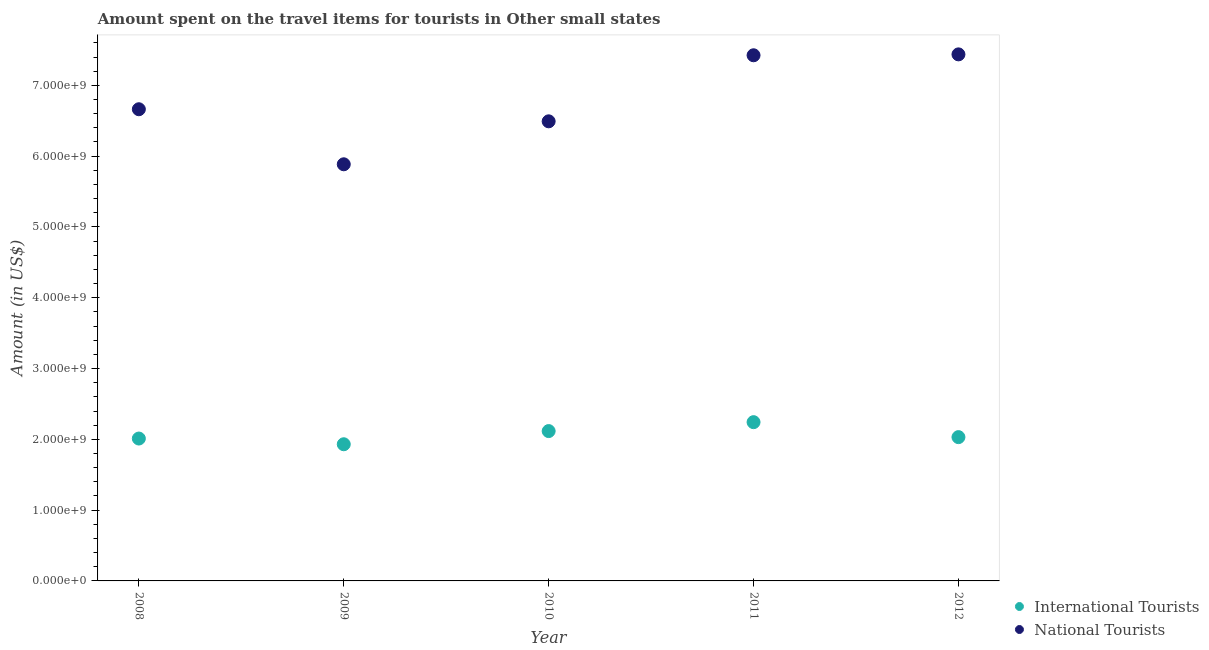How many different coloured dotlines are there?
Provide a short and direct response. 2. What is the amount spent on travel items of national tourists in 2008?
Give a very brief answer. 6.66e+09. Across all years, what is the maximum amount spent on travel items of national tourists?
Your response must be concise. 7.44e+09. Across all years, what is the minimum amount spent on travel items of international tourists?
Provide a short and direct response. 1.93e+09. In which year was the amount spent on travel items of national tourists maximum?
Keep it short and to the point. 2012. What is the total amount spent on travel items of national tourists in the graph?
Ensure brevity in your answer.  3.39e+1. What is the difference between the amount spent on travel items of national tourists in 2010 and that in 2011?
Offer a terse response. -9.33e+08. What is the difference between the amount spent on travel items of national tourists in 2012 and the amount spent on travel items of international tourists in 2009?
Your answer should be very brief. 5.51e+09. What is the average amount spent on travel items of national tourists per year?
Offer a very short reply. 6.78e+09. In the year 2008, what is the difference between the amount spent on travel items of national tourists and amount spent on travel items of international tourists?
Give a very brief answer. 4.65e+09. In how many years, is the amount spent on travel items of national tourists greater than 6200000000 US$?
Offer a very short reply. 4. What is the ratio of the amount spent on travel items of international tourists in 2008 to that in 2011?
Keep it short and to the point. 0.9. Is the amount spent on travel items of international tourists in 2009 less than that in 2011?
Offer a very short reply. Yes. What is the difference between the highest and the second highest amount spent on travel items of international tourists?
Give a very brief answer. 1.26e+08. What is the difference between the highest and the lowest amount spent on travel items of national tourists?
Offer a very short reply. 1.55e+09. Is the amount spent on travel items of international tourists strictly greater than the amount spent on travel items of national tourists over the years?
Offer a terse response. No. Is the amount spent on travel items of national tourists strictly less than the amount spent on travel items of international tourists over the years?
Provide a short and direct response. No. How many dotlines are there?
Your response must be concise. 2. How many years are there in the graph?
Your answer should be very brief. 5. What is the difference between two consecutive major ticks on the Y-axis?
Offer a terse response. 1.00e+09. Does the graph contain any zero values?
Provide a succinct answer. No. What is the title of the graph?
Provide a succinct answer. Amount spent on the travel items for tourists in Other small states. What is the Amount (in US$) of International Tourists in 2008?
Ensure brevity in your answer.  2.01e+09. What is the Amount (in US$) in National Tourists in 2008?
Offer a terse response. 6.66e+09. What is the Amount (in US$) in International Tourists in 2009?
Keep it short and to the point. 1.93e+09. What is the Amount (in US$) of National Tourists in 2009?
Your answer should be very brief. 5.88e+09. What is the Amount (in US$) of International Tourists in 2010?
Provide a short and direct response. 2.12e+09. What is the Amount (in US$) of National Tourists in 2010?
Your answer should be very brief. 6.49e+09. What is the Amount (in US$) in International Tourists in 2011?
Your answer should be very brief. 2.24e+09. What is the Amount (in US$) in National Tourists in 2011?
Ensure brevity in your answer.  7.42e+09. What is the Amount (in US$) in International Tourists in 2012?
Give a very brief answer. 2.03e+09. What is the Amount (in US$) of National Tourists in 2012?
Keep it short and to the point. 7.44e+09. Across all years, what is the maximum Amount (in US$) of International Tourists?
Your answer should be compact. 2.24e+09. Across all years, what is the maximum Amount (in US$) in National Tourists?
Make the answer very short. 7.44e+09. Across all years, what is the minimum Amount (in US$) in International Tourists?
Your response must be concise. 1.93e+09. Across all years, what is the minimum Amount (in US$) in National Tourists?
Give a very brief answer. 5.88e+09. What is the total Amount (in US$) in International Tourists in the graph?
Offer a terse response. 1.03e+1. What is the total Amount (in US$) of National Tourists in the graph?
Keep it short and to the point. 3.39e+1. What is the difference between the Amount (in US$) of International Tourists in 2008 and that in 2009?
Provide a succinct answer. 8.07e+07. What is the difference between the Amount (in US$) in National Tourists in 2008 and that in 2009?
Provide a succinct answer. 7.78e+08. What is the difference between the Amount (in US$) of International Tourists in 2008 and that in 2010?
Ensure brevity in your answer.  -1.05e+08. What is the difference between the Amount (in US$) in National Tourists in 2008 and that in 2010?
Provide a succinct answer. 1.71e+08. What is the difference between the Amount (in US$) in International Tourists in 2008 and that in 2011?
Offer a very short reply. -2.31e+08. What is the difference between the Amount (in US$) of National Tourists in 2008 and that in 2011?
Ensure brevity in your answer.  -7.62e+08. What is the difference between the Amount (in US$) of International Tourists in 2008 and that in 2012?
Make the answer very short. -1.99e+07. What is the difference between the Amount (in US$) of National Tourists in 2008 and that in 2012?
Ensure brevity in your answer.  -7.75e+08. What is the difference between the Amount (in US$) of International Tourists in 2009 and that in 2010?
Give a very brief answer. -1.86e+08. What is the difference between the Amount (in US$) in National Tourists in 2009 and that in 2010?
Offer a very short reply. -6.07e+08. What is the difference between the Amount (in US$) in International Tourists in 2009 and that in 2011?
Offer a very short reply. -3.12e+08. What is the difference between the Amount (in US$) of National Tourists in 2009 and that in 2011?
Provide a short and direct response. -1.54e+09. What is the difference between the Amount (in US$) in International Tourists in 2009 and that in 2012?
Offer a very short reply. -1.01e+08. What is the difference between the Amount (in US$) of National Tourists in 2009 and that in 2012?
Offer a terse response. -1.55e+09. What is the difference between the Amount (in US$) in International Tourists in 2010 and that in 2011?
Provide a short and direct response. -1.26e+08. What is the difference between the Amount (in US$) in National Tourists in 2010 and that in 2011?
Offer a very short reply. -9.33e+08. What is the difference between the Amount (in US$) in International Tourists in 2010 and that in 2012?
Offer a very short reply. 8.54e+07. What is the difference between the Amount (in US$) in National Tourists in 2010 and that in 2012?
Keep it short and to the point. -9.46e+08. What is the difference between the Amount (in US$) in International Tourists in 2011 and that in 2012?
Give a very brief answer. 2.11e+08. What is the difference between the Amount (in US$) of National Tourists in 2011 and that in 2012?
Give a very brief answer. -1.28e+07. What is the difference between the Amount (in US$) of International Tourists in 2008 and the Amount (in US$) of National Tourists in 2009?
Make the answer very short. -3.87e+09. What is the difference between the Amount (in US$) in International Tourists in 2008 and the Amount (in US$) in National Tourists in 2010?
Provide a succinct answer. -4.48e+09. What is the difference between the Amount (in US$) in International Tourists in 2008 and the Amount (in US$) in National Tourists in 2011?
Ensure brevity in your answer.  -5.41e+09. What is the difference between the Amount (in US$) in International Tourists in 2008 and the Amount (in US$) in National Tourists in 2012?
Provide a succinct answer. -5.43e+09. What is the difference between the Amount (in US$) in International Tourists in 2009 and the Amount (in US$) in National Tourists in 2010?
Offer a terse response. -4.56e+09. What is the difference between the Amount (in US$) of International Tourists in 2009 and the Amount (in US$) of National Tourists in 2011?
Your response must be concise. -5.49e+09. What is the difference between the Amount (in US$) in International Tourists in 2009 and the Amount (in US$) in National Tourists in 2012?
Your answer should be very brief. -5.51e+09. What is the difference between the Amount (in US$) in International Tourists in 2010 and the Amount (in US$) in National Tourists in 2011?
Your response must be concise. -5.31e+09. What is the difference between the Amount (in US$) of International Tourists in 2010 and the Amount (in US$) of National Tourists in 2012?
Ensure brevity in your answer.  -5.32e+09. What is the difference between the Amount (in US$) in International Tourists in 2011 and the Amount (in US$) in National Tourists in 2012?
Provide a succinct answer. -5.20e+09. What is the average Amount (in US$) of International Tourists per year?
Offer a very short reply. 2.07e+09. What is the average Amount (in US$) of National Tourists per year?
Offer a terse response. 6.78e+09. In the year 2008, what is the difference between the Amount (in US$) of International Tourists and Amount (in US$) of National Tourists?
Provide a succinct answer. -4.65e+09. In the year 2009, what is the difference between the Amount (in US$) of International Tourists and Amount (in US$) of National Tourists?
Your answer should be very brief. -3.95e+09. In the year 2010, what is the difference between the Amount (in US$) of International Tourists and Amount (in US$) of National Tourists?
Provide a succinct answer. -4.38e+09. In the year 2011, what is the difference between the Amount (in US$) in International Tourists and Amount (in US$) in National Tourists?
Offer a terse response. -5.18e+09. In the year 2012, what is the difference between the Amount (in US$) of International Tourists and Amount (in US$) of National Tourists?
Make the answer very short. -5.41e+09. What is the ratio of the Amount (in US$) of International Tourists in 2008 to that in 2009?
Make the answer very short. 1.04. What is the ratio of the Amount (in US$) of National Tourists in 2008 to that in 2009?
Provide a short and direct response. 1.13. What is the ratio of the Amount (in US$) of International Tourists in 2008 to that in 2010?
Give a very brief answer. 0.95. What is the ratio of the Amount (in US$) in National Tourists in 2008 to that in 2010?
Offer a terse response. 1.03. What is the ratio of the Amount (in US$) in International Tourists in 2008 to that in 2011?
Make the answer very short. 0.9. What is the ratio of the Amount (in US$) in National Tourists in 2008 to that in 2011?
Ensure brevity in your answer.  0.9. What is the ratio of the Amount (in US$) in International Tourists in 2008 to that in 2012?
Offer a terse response. 0.99. What is the ratio of the Amount (in US$) of National Tourists in 2008 to that in 2012?
Your answer should be very brief. 0.9. What is the ratio of the Amount (in US$) of International Tourists in 2009 to that in 2010?
Ensure brevity in your answer.  0.91. What is the ratio of the Amount (in US$) in National Tourists in 2009 to that in 2010?
Make the answer very short. 0.91. What is the ratio of the Amount (in US$) of International Tourists in 2009 to that in 2011?
Provide a succinct answer. 0.86. What is the ratio of the Amount (in US$) of National Tourists in 2009 to that in 2011?
Your response must be concise. 0.79. What is the ratio of the Amount (in US$) of International Tourists in 2009 to that in 2012?
Keep it short and to the point. 0.95. What is the ratio of the Amount (in US$) of National Tourists in 2009 to that in 2012?
Provide a succinct answer. 0.79. What is the ratio of the Amount (in US$) of International Tourists in 2010 to that in 2011?
Ensure brevity in your answer.  0.94. What is the ratio of the Amount (in US$) in National Tourists in 2010 to that in 2011?
Your answer should be compact. 0.87. What is the ratio of the Amount (in US$) of International Tourists in 2010 to that in 2012?
Ensure brevity in your answer.  1.04. What is the ratio of the Amount (in US$) of National Tourists in 2010 to that in 2012?
Your answer should be very brief. 0.87. What is the ratio of the Amount (in US$) of International Tourists in 2011 to that in 2012?
Provide a short and direct response. 1.1. What is the difference between the highest and the second highest Amount (in US$) in International Tourists?
Keep it short and to the point. 1.26e+08. What is the difference between the highest and the second highest Amount (in US$) in National Tourists?
Keep it short and to the point. 1.28e+07. What is the difference between the highest and the lowest Amount (in US$) of International Tourists?
Ensure brevity in your answer.  3.12e+08. What is the difference between the highest and the lowest Amount (in US$) of National Tourists?
Make the answer very short. 1.55e+09. 